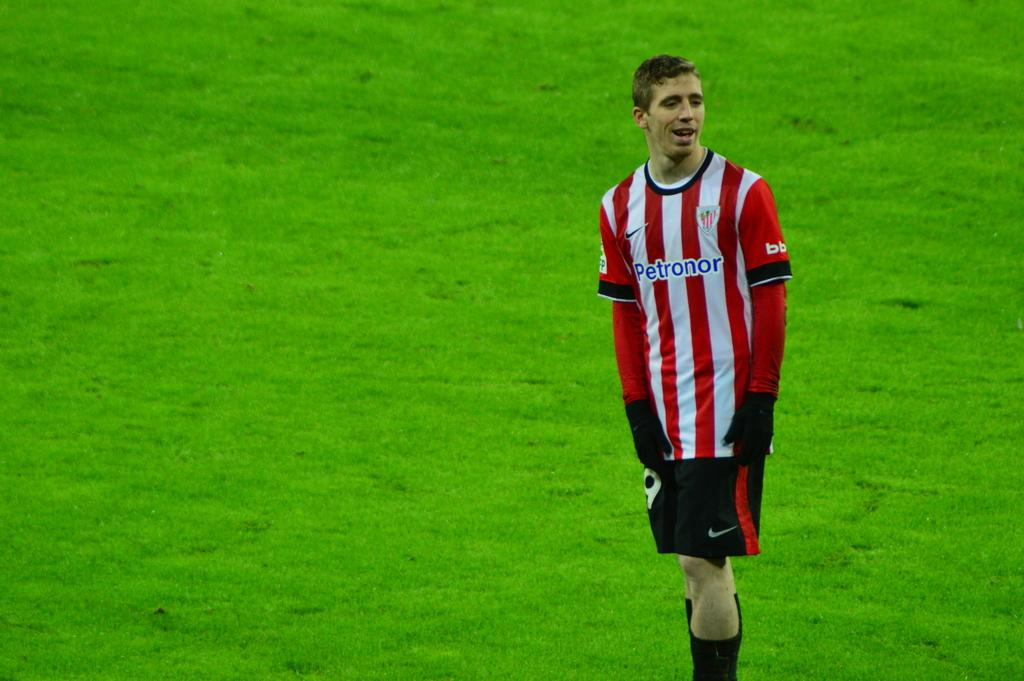<image>
Give a short and clear explanation of the subsequent image. a player with a Petronor jersey on a soccer field 